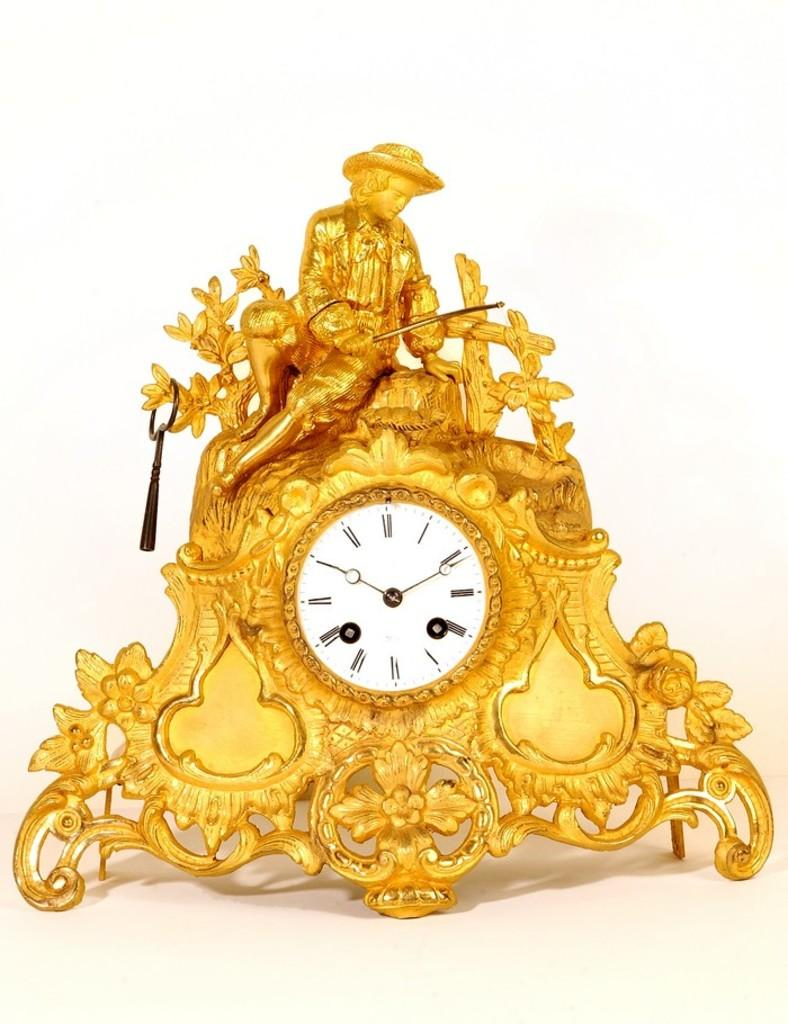What object is present in the image that is used for telling time? There is a clock in the image that is used for telling time. Where is the clock located in the image? The clock is placed on a surface in the image. What type of flock can be seen flying in the image? There is no flock of birds or any other animals present in the image; it only features a clock placed on a surface. 